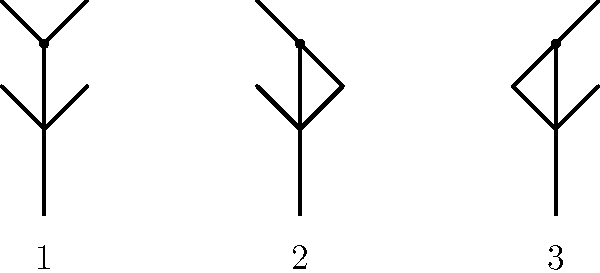As a DJ, you often observe dance moves on the dance floor. Which popular dance move is represented by the sequence of stick figure animations above? To identify the dance move, let's analyze the sequence of stick figure animations:

1. In the first position (1), the stick figure has both arms raised above the head and both legs straight.

2. In the second position (2), the right arm remains raised while the left arm is lowered. The right leg is bent at the knee.

3. In the third position (3), the left arm is raised while the right arm is lowered. The left leg is bent at the knee, mirroring the previous position.

This alternating pattern of arm and leg movements, where one side of the body is raised while the other is lowered, is characteristic of the popular dance move known as "The Running Man."

The Running Man is a dance move that simulates a running motion while staying in place. It involves alternating arm and leg movements to create the illusion of running. This dance move became popular in the 1980s and 1990s and is often associated with hip-hop and electronic dance music.

As a professional DJ, recognizing this dance move is important for understanding crowd engagement and selecting appropriate music to keep the energy high on the dance floor.
Answer: The Running Man 